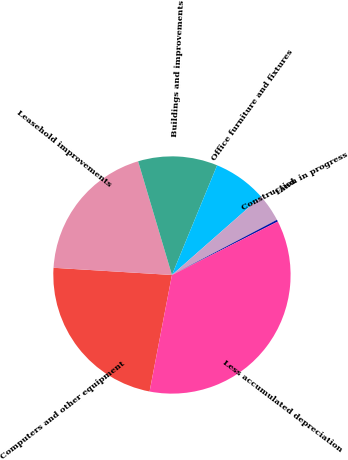Convert chart. <chart><loc_0><loc_0><loc_500><loc_500><pie_chart><fcel>Computers and other equipment<fcel>Leasehold improvements<fcel>Buildings and improvements<fcel>Office furniture and fixtures<fcel>Land<fcel>Construction in progress<fcel>Less accumulated depreciation<nl><fcel>22.95%<fcel>19.43%<fcel>10.82%<fcel>7.3%<fcel>3.78%<fcel>0.26%<fcel>35.46%<nl></chart> 